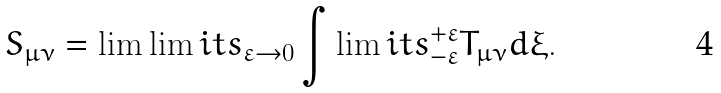Convert formula to latex. <formula><loc_0><loc_0><loc_500><loc_500>S _ { \mu \nu } = \lim \lim i t s _ { \varepsilon \rightarrow 0 } \int \lim i t s _ { - \varepsilon } ^ { + \varepsilon } T _ { \mu \nu } d \xi .</formula> 